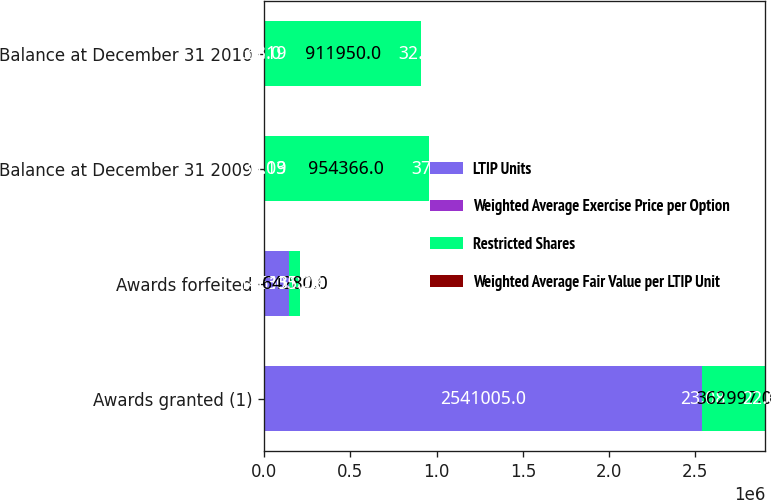Convert chart. <chart><loc_0><loc_0><loc_500><loc_500><stacked_bar_chart><ecel><fcel>Awards granted (1)<fcel>Awards forfeited<fcel>Balance at December 31 2009<fcel>Balance at December 31 2010<nl><fcel>LTIP Units<fcel>2.541e+06<fcel>146151<fcel>36.19<fcel>36.19<nl><fcel>Weighted Average Exercise Price per Option<fcel>23.08<fcel>30.07<fcel>32.03<fcel>33<nl><fcel>Restricted Shares<fcel>362997<fcel>64280<fcel>954366<fcel>911950<nl><fcel>Weighted Average Fair Value per LTIP Unit<fcel>22.62<fcel>35.28<fcel>37.1<fcel>32.05<nl></chart> 